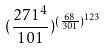<formula> <loc_0><loc_0><loc_500><loc_500>( \frac { 2 7 1 ^ { 4 } } { 1 0 1 } ) ^ { ( \frac { 6 8 } { 3 0 1 } ) ^ { 1 2 3 } }</formula> 